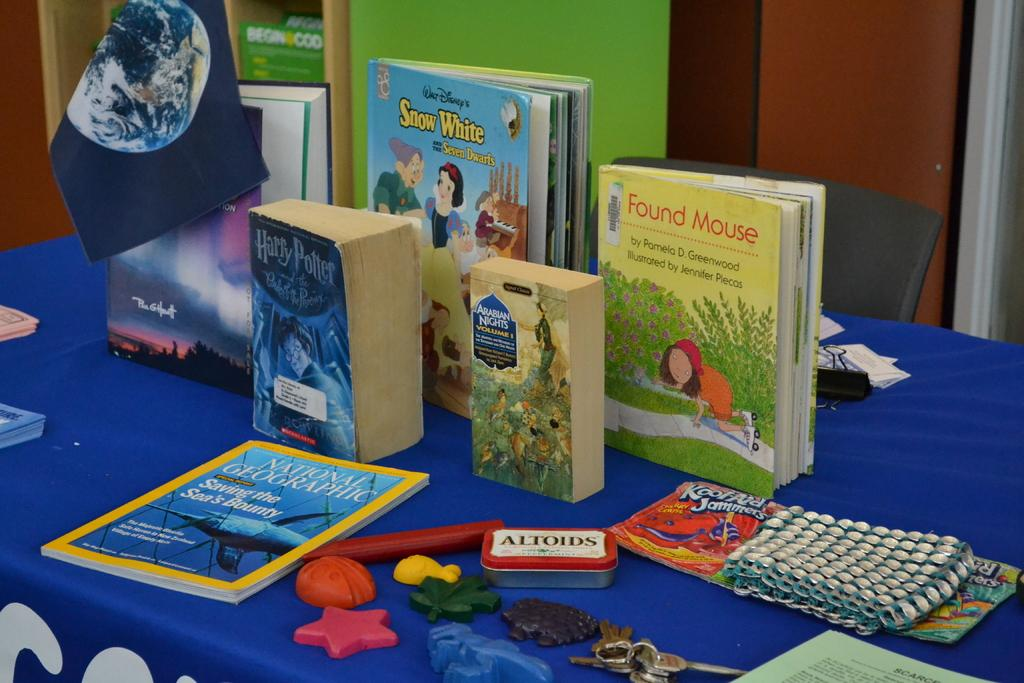Provide a one-sentence caption for the provided image. Books are on a table with a container of Altoids in the middle. 